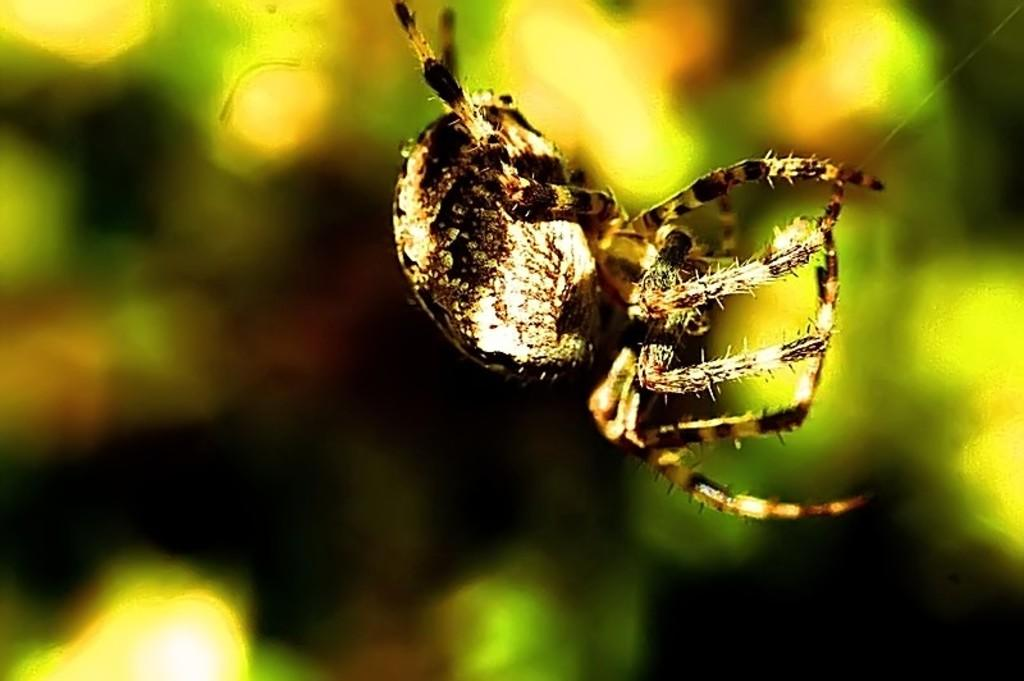What is the main subject of the image? The main subject of the image is a spider. What is the spider doing in the image? The spider is holding a web. What can be seen in the background of the image? There is a plant visible in the background of the image. What is the level of anger displayed by the desk in the image? There is no desk present in the image, so it is not possible to determine the level of anger displayed by a desk. 